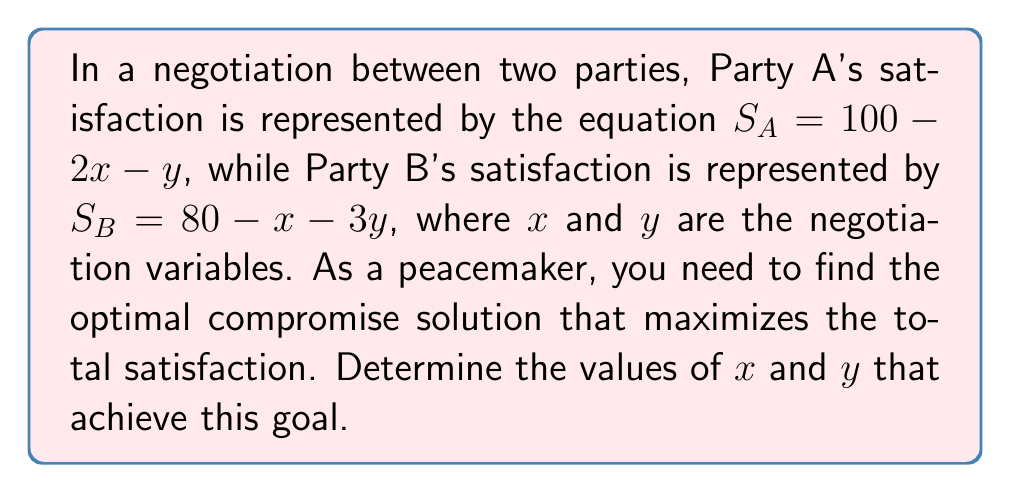Could you help me with this problem? 1. To find the optimal compromise, we need to maximize the total satisfaction:
   $$S_{total} = S_A + S_B = (100 - 2x - y) + (80 - x - 3y)$$

2. Simplify the equation:
   $$S_{total} = 180 - 3x - 4y$$

3. To maximize $S_{total}$, we need to find the partial derivatives with respect to $x$ and $y$ and set them to zero:

   $$\frac{\partial S_{total}}{\partial x} = -3 = 0$$
   $$\frac{\partial S_{total}}{\partial y} = -4 = 0$$

4. Since both partial derivatives are constants and not zero, there is no interior maximum point. This means the optimal solution lies on the boundaries of the feasible region.

5. The feasible region is constrained by the non-negativity of $x$ and $y$, and the requirement that both parties' satisfactions must be non-negative:

   $$x \geq 0, y \geq 0$$
   $$100 - 2x - y \geq 0$$
   $$80 - x - 3y \geq 0$$

6. The optimal solution will be at the point where the two constraint lines intersect:

   $$100 - 2x - y = 0$$
   $$80 - x - 3y = 0$$

7. Solve this system of equations:
   Multiply the first equation by 3 and the second by 1:
   $$300 - 6x - 3y = 0$$
   $$80 - x - 3y = 0$$

   Subtract the second equation from the first:
   $$220 - 5x = 0$$
   $$x = 44$$

   Substitute $x = 44$ into the second equation:
   $$80 - 44 - 3y = 0$$
   $$36 = 3y$$
   $$y = 12$$

8. Check that this solution satisfies all constraints and maximizes total satisfaction.
Answer: $x = 44, y = 12$ 